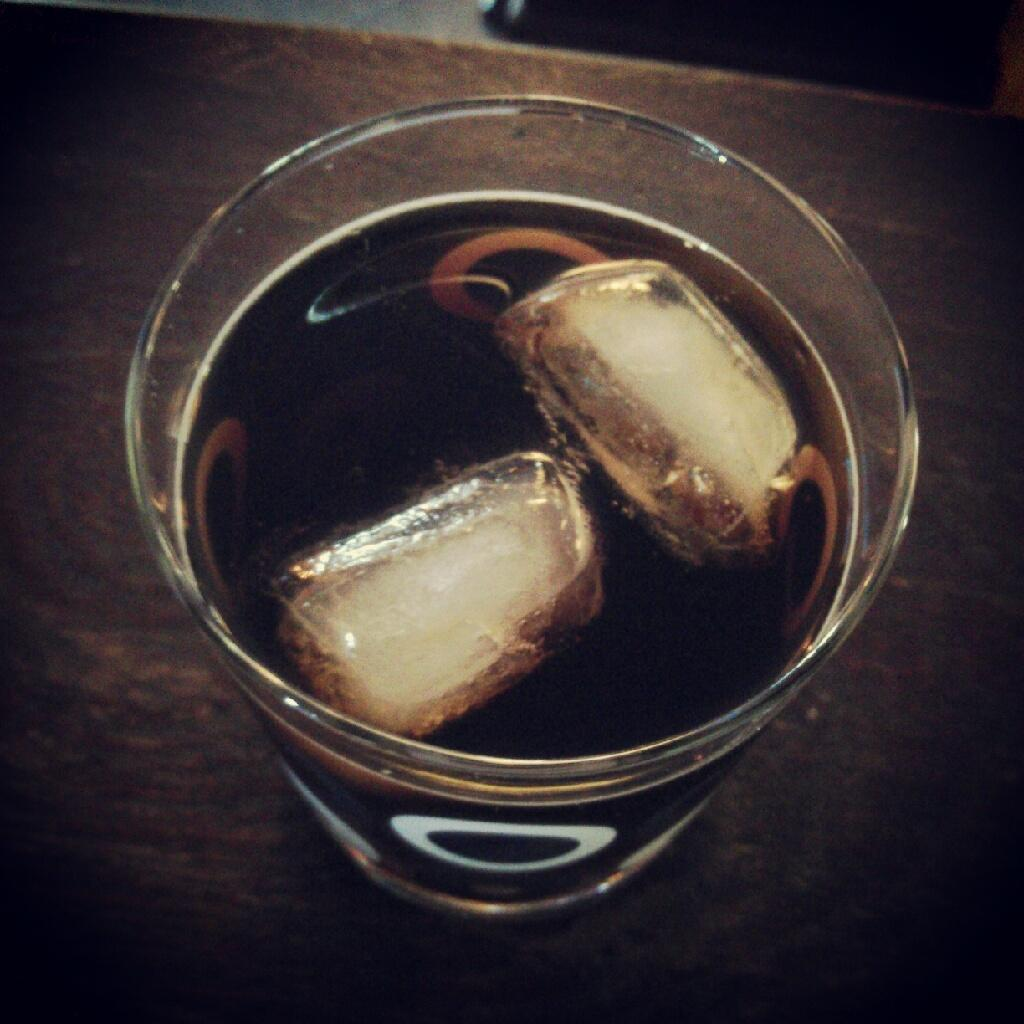What is in the glass that is visible in the image? The glass contains ice cubes and a beverage. What else can be seen in the image besides the glass? There is a table in the image. How many babies are crawling on the table in the image? There are no babies present in the image; it only features a glass with ice cubes and a beverage on a table. 